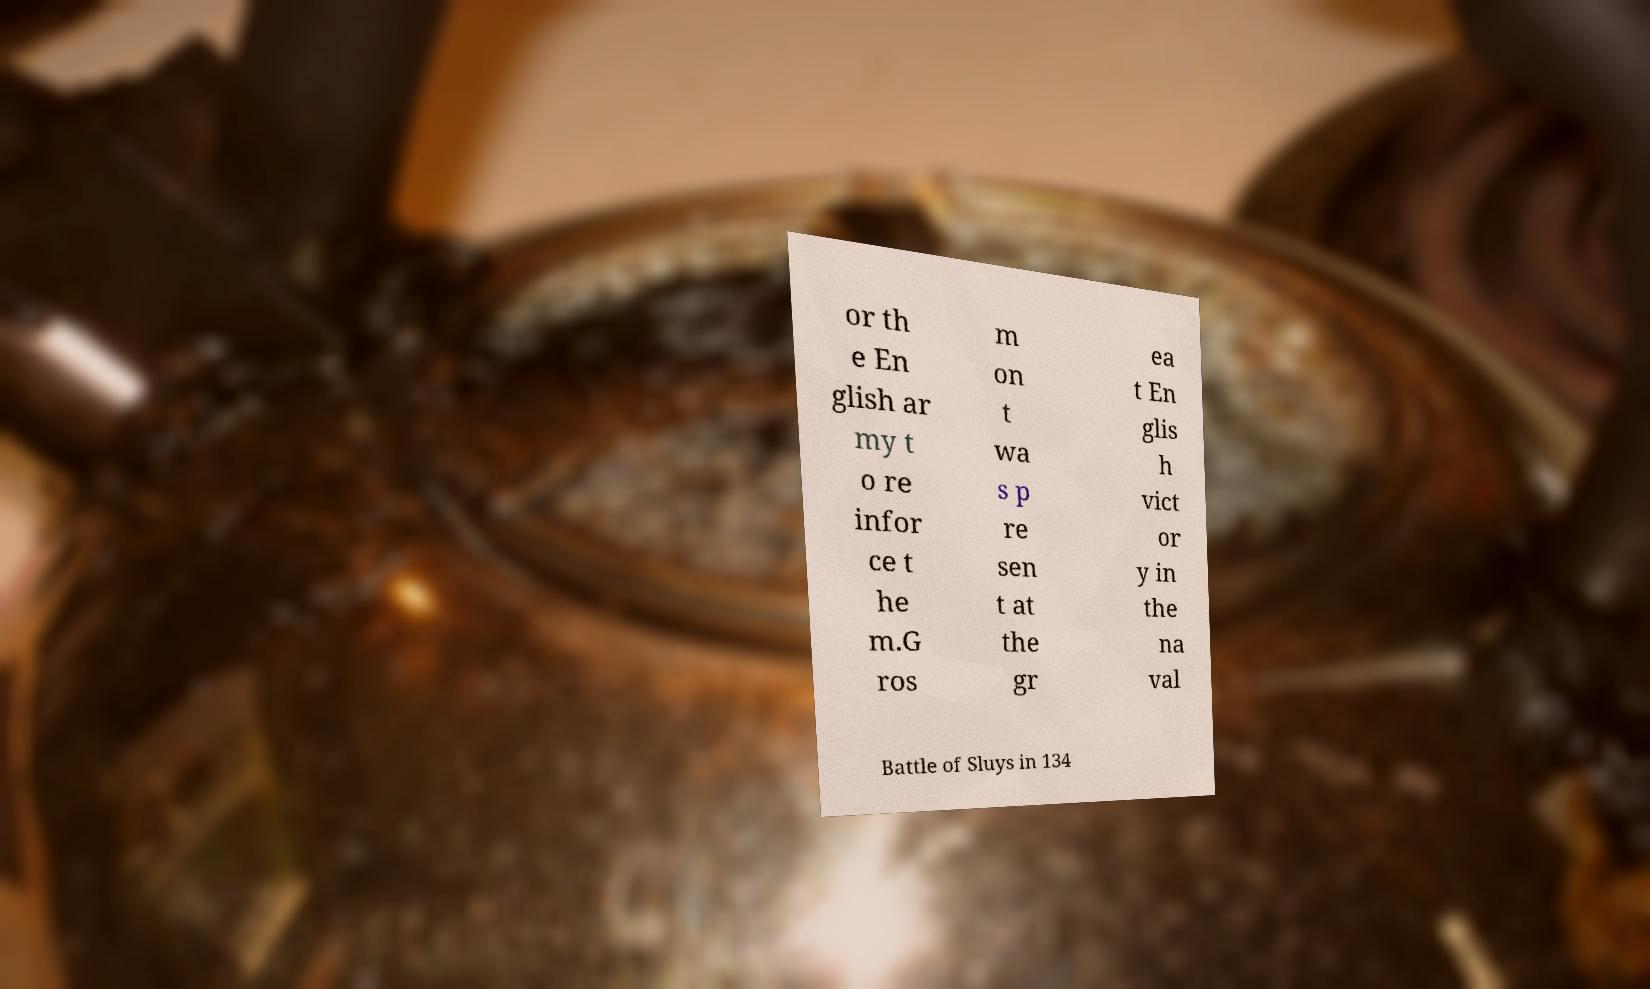There's text embedded in this image that I need extracted. Can you transcribe it verbatim? or th e En glish ar my t o re infor ce t he m.G ros m on t wa s p re sen t at the gr ea t En glis h vict or y in the na val Battle of Sluys in 134 